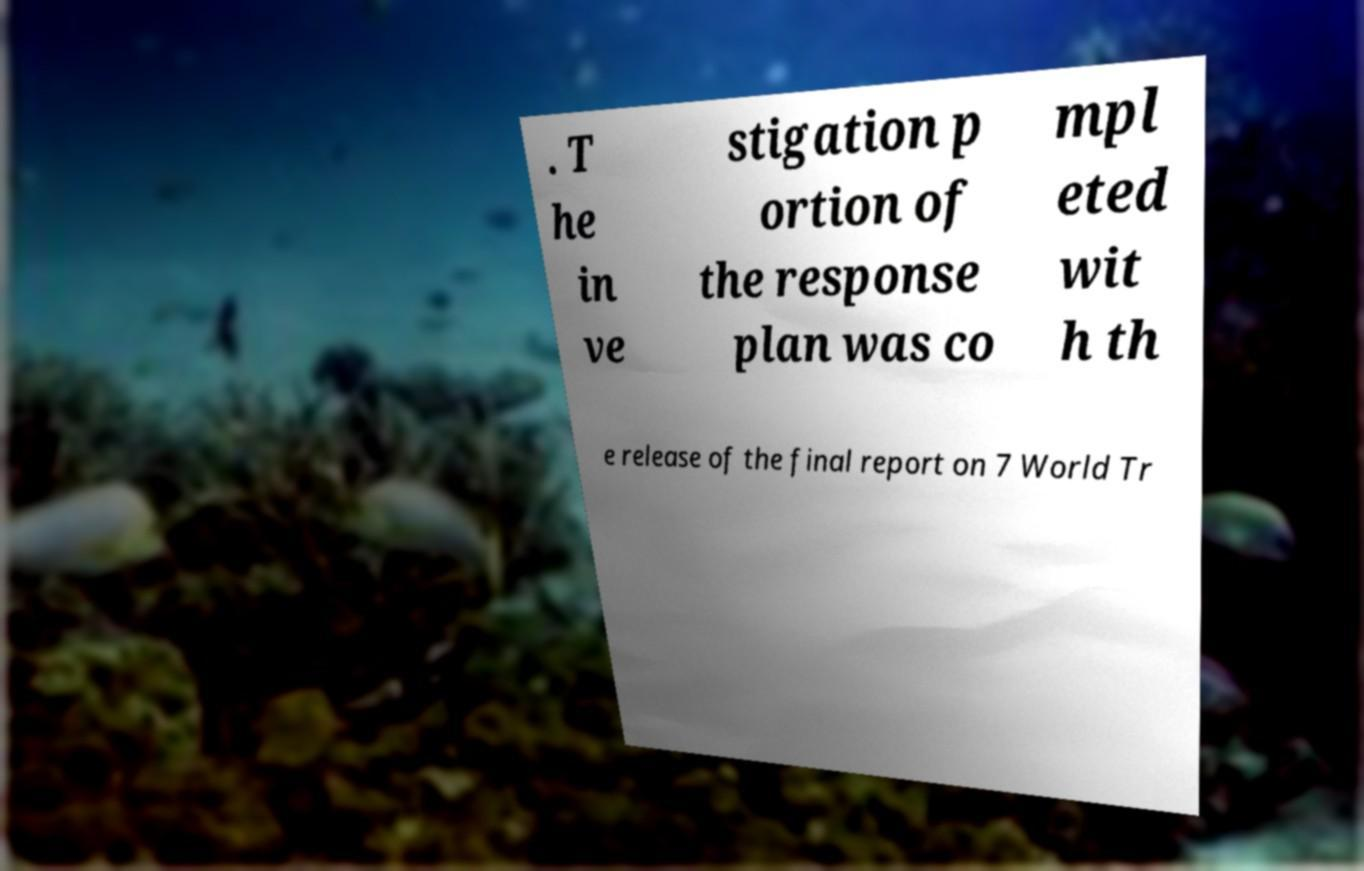Please identify and transcribe the text found in this image. . T he in ve stigation p ortion of the response plan was co mpl eted wit h th e release of the final report on 7 World Tr 